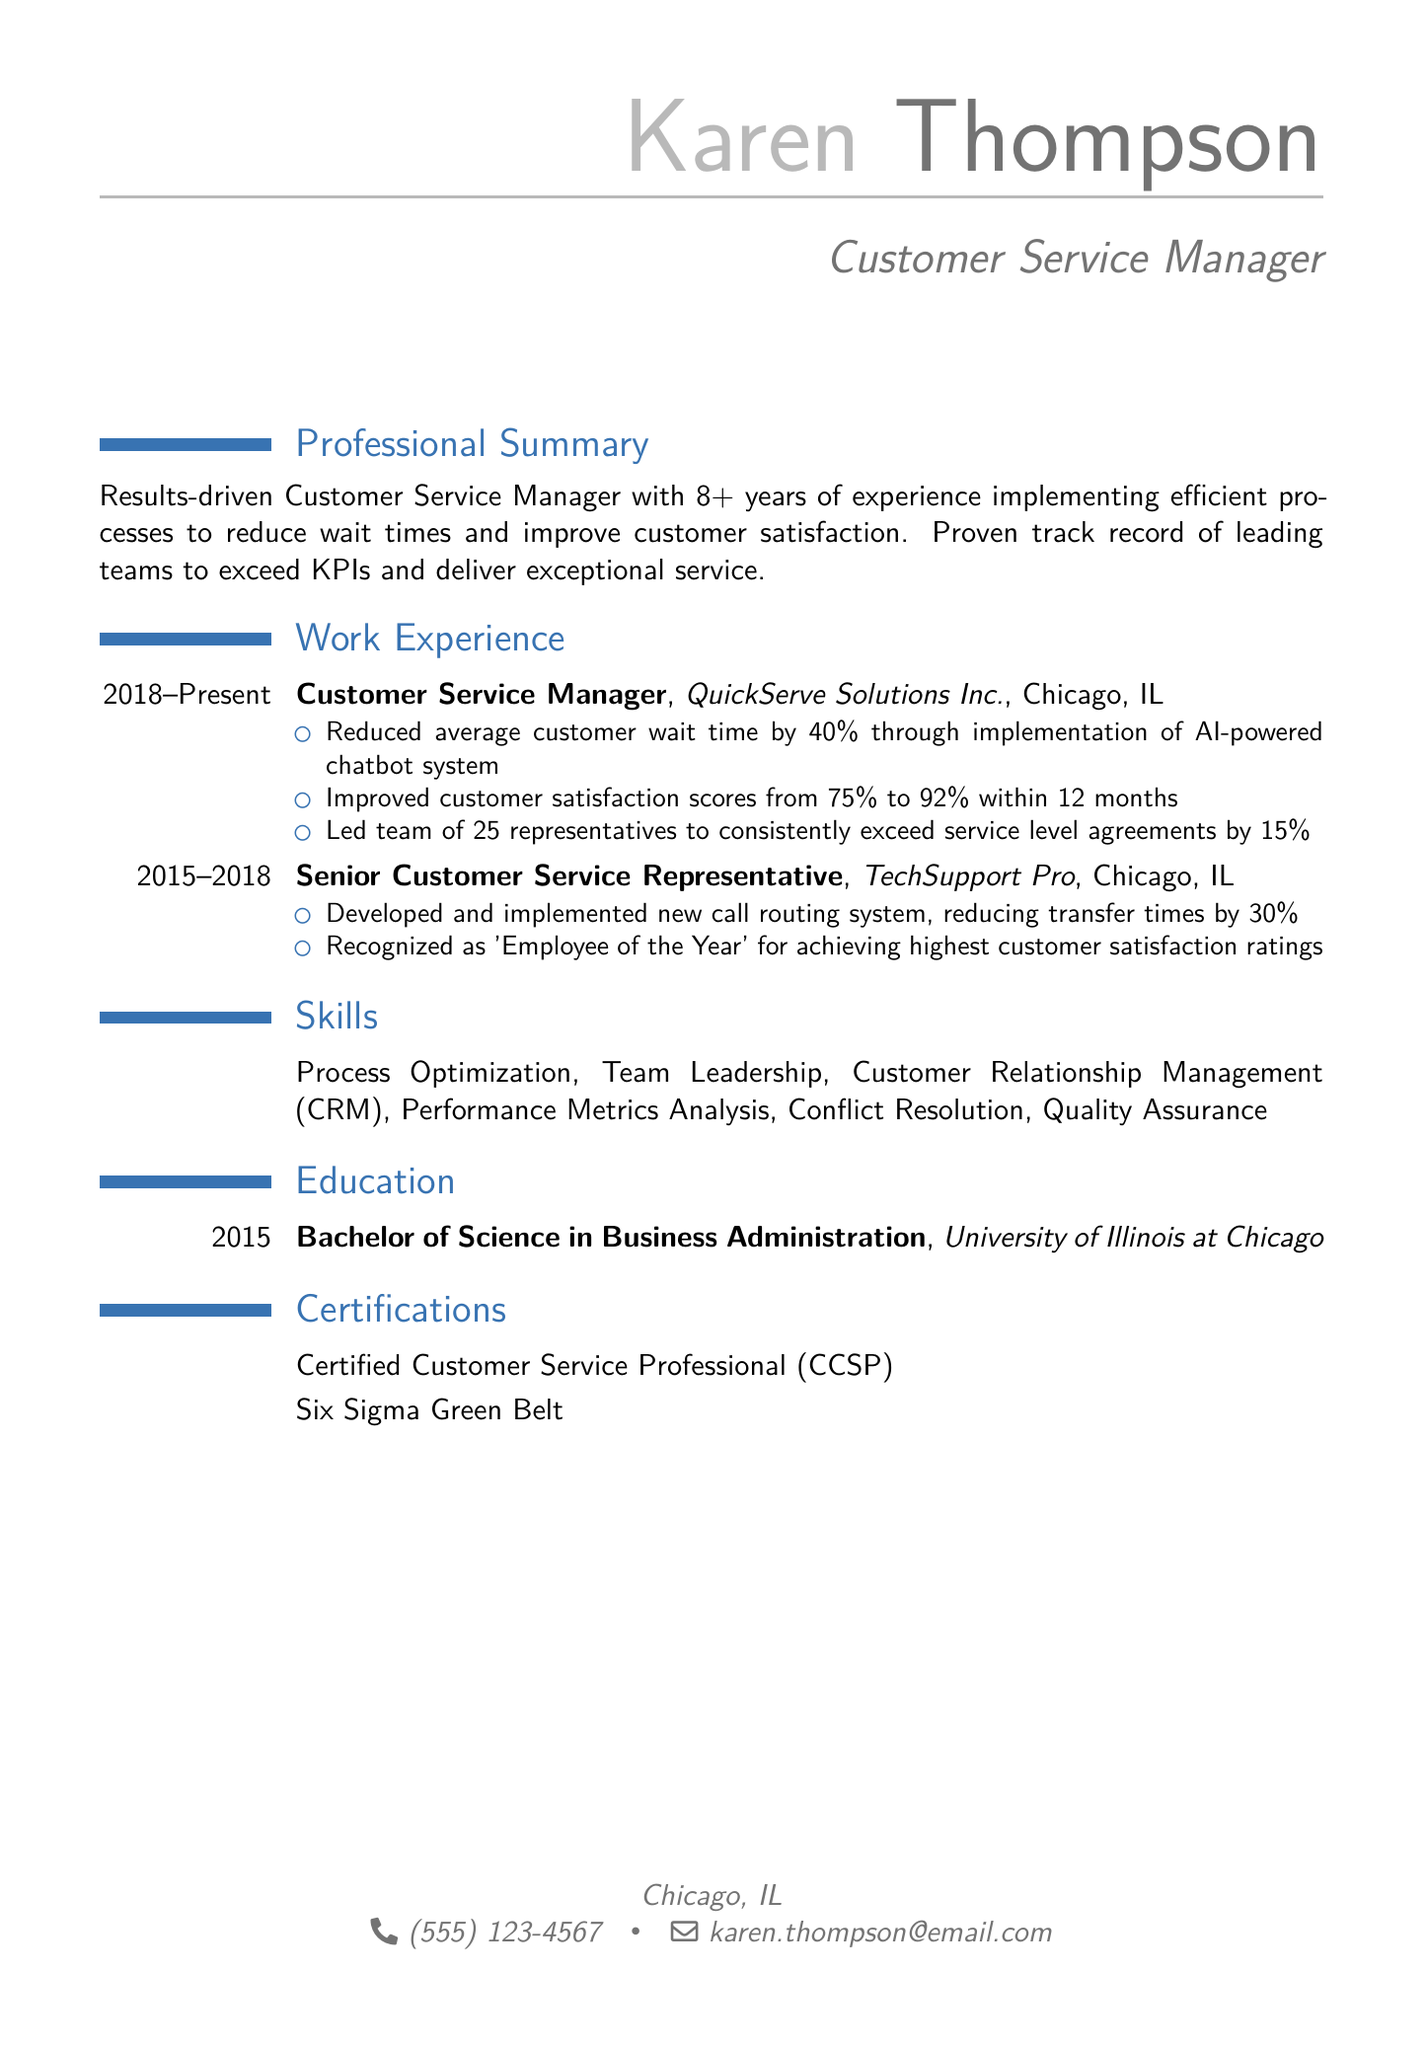What is the name of the individual? The name is explicitly stated at the top of the resume.
Answer: Karen Thompson What is the email address provided? The email address is listed under personal information.
Answer: karen.thompson@email.com What was the average customer wait time reduction achieved? This information is specified in the achievements section of the work experience.
Answer: 40% How many years of experience does Karen have? The professional summary clearly mentions the number of years of experience.
Answer: 8+ What position did Karen hold at QuickServe Solutions Inc.? This is outlined in the work experience section.
Answer: Customer Service Manager What was the customer satisfaction score increase achieved by Karen? The improvement is noted in her achievements.
Answer: 17% What degree does Karen hold? This is mentioned in the education section of the resume.
Answer: Bachelor of Science in Business Administration Which certification indicates expertise in customer service? This is found in the certifications section.
Answer: Certified Customer Service Professional (CCSP) How many representatives did Karen lead at QuickServe Solutions Inc.? The information is provided in the achievements of her work experience.
Answer: 25 